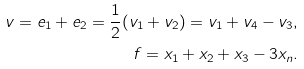Convert formula to latex. <formula><loc_0><loc_0><loc_500><loc_500>v = e _ { 1 } + e _ { 2 } = \frac { 1 } { 2 } ( v _ { 1 } + v _ { 2 } ) = v _ { 1 } + v _ { 4 } - v _ { 3 } , \\ f = x _ { 1 } + x _ { 2 } + x _ { 3 } - 3 x _ { n } .</formula> 